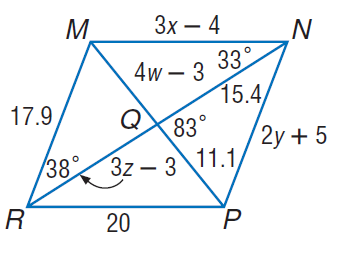Answer the mathemtical geometry problem and directly provide the correct option letter.
Question: Use parallelogram M N P R to find w.
Choices: A: 3.5 B: 11 C: 11.1 D: 14 A 